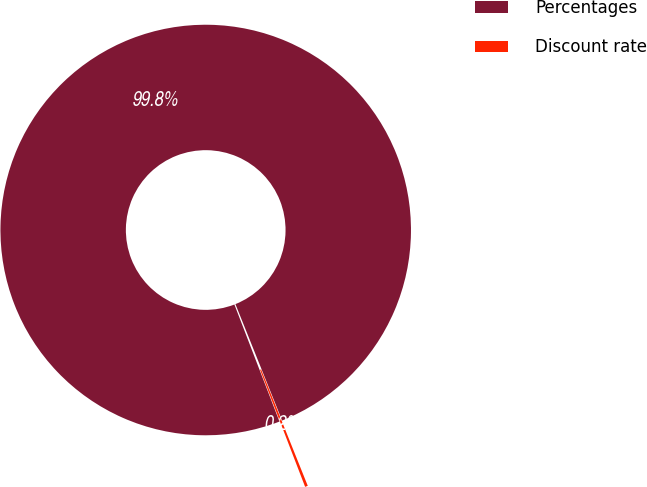Convert chart to OTSL. <chart><loc_0><loc_0><loc_500><loc_500><pie_chart><fcel>Percentages<fcel>Discount rate<nl><fcel>99.78%<fcel>0.22%<nl></chart> 